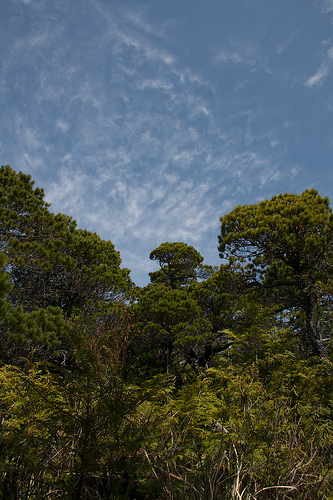<image>
Is there a clouds behind the tree? Yes. From this viewpoint, the clouds is positioned behind the tree, with the tree partially or fully occluding the clouds. 